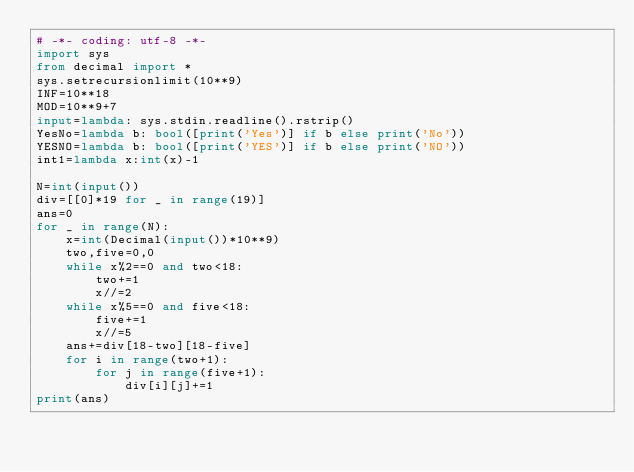<code> <loc_0><loc_0><loc_500><loc_500><_Python_># -*- coding: utf-8 -*-
import sys
from decimal import *
sys.setrecursionlimit(10**9)
INF=10**18
MOD=10**9+7
input=lambda: sys.stdin.readline().rstrip()
YesNo=lambda b: bool([print('Yes')] if b else print('No'))
YESNO=lambda b: bool([print('YES')] if b else print('NO'))
int1=lambda x:int(x)-1

N=int(input())
div=[[0]*19 for _ in range(19)]
ans=0
for _ in range(N):
    x=int(Decimal(input())*10**9)
    two,five=0,0
    while x%2==0 and two<18:
        two+=1
        x//=2
    while x%5==0 and five<18:
        five+=1
        x//=5
    ans+=div[18-two][18-five]
    for i in range(two+1):
        for j in range(five+1):
            div[i][j]+=1
print(ans)</code> 